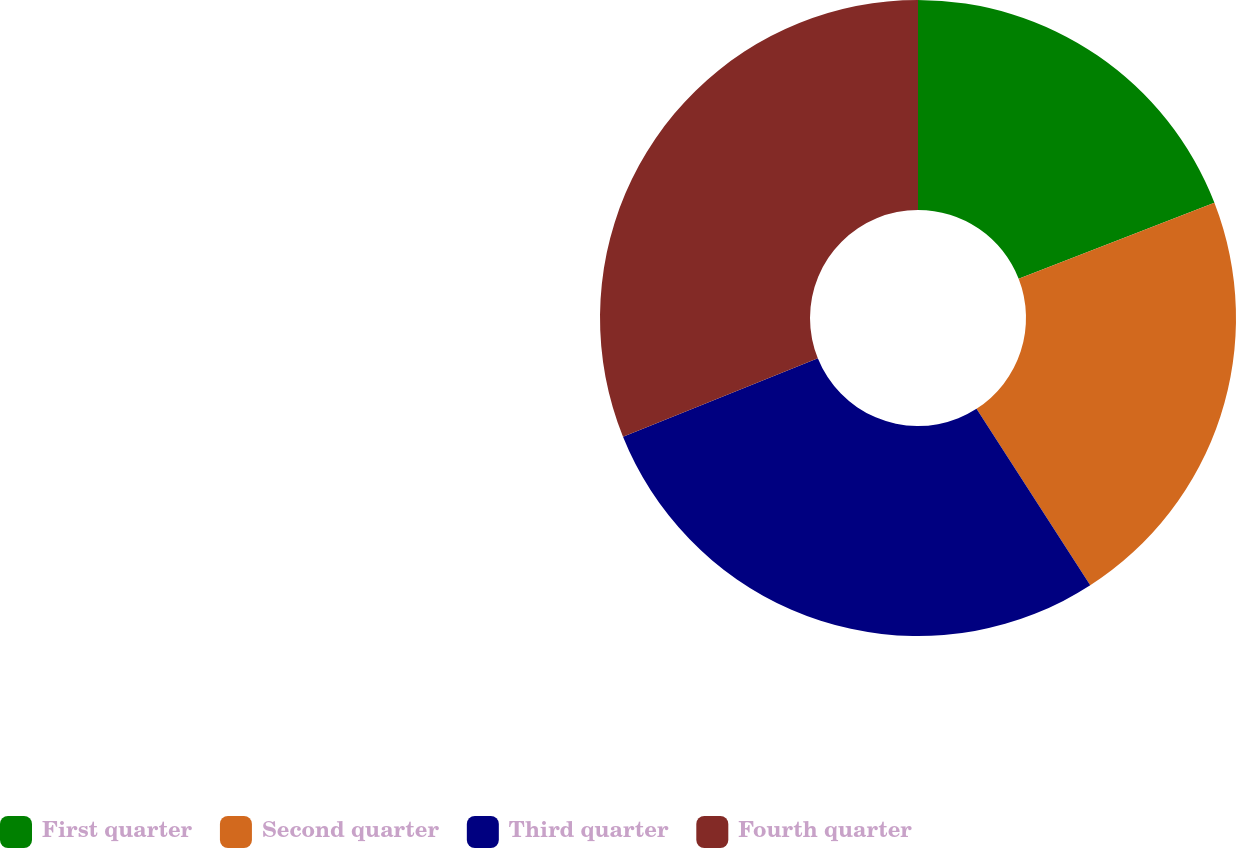<chart> <loc_0><loc_0><loc_500><loc_500><pie_chart><fcel>First quarter<fcel>Second quarter<fcel>Third quarter<fcel>Fourth quarter<nl><fcel>19.1%<fcel>21.79%<fcel>28.02%<fcel>31.09%<nl></chart> 